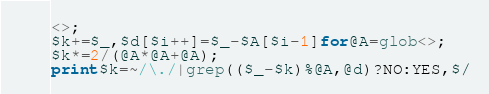Convert code to text. <code><loc_0><loc_0><loc_500><loc_500><_Perl_><>;
$k+=$_,$d[$i++]=$_-$A[$i-1]for@A=glob<>;
$k*=2/(@A*@A+@A);
print$k=~/\./|grep(($_-$k)%@A,@d)?NO:YES,$/
</code> 